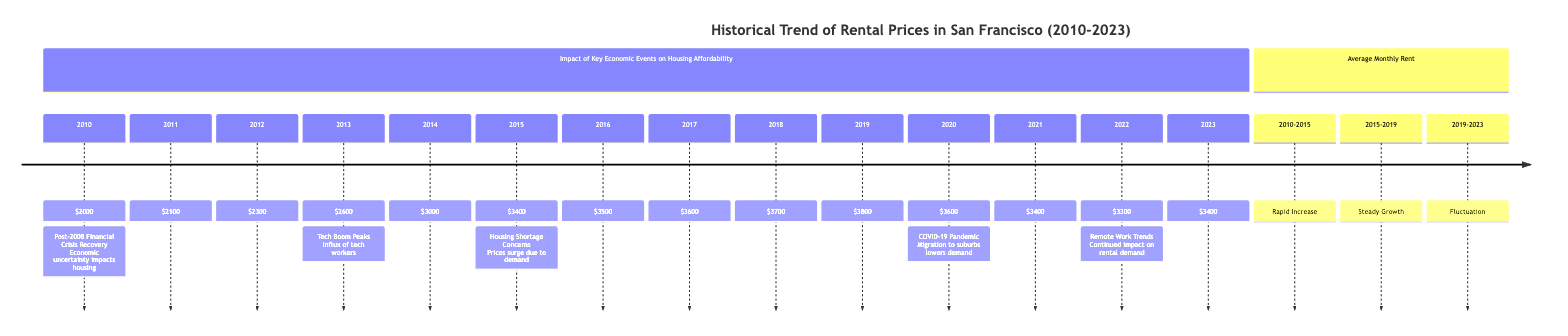What was the rental price in 2013? According to the diagram, the rental price in 2013 is marked as $2600.
Answer: $2600 What economic event is noted for 2020? The diagram indicates that the COVID-19 Pandemic is the key economic event for the year 2020.
Answer: COVID-19 Pandemic Which year saw the highest rental price? The rental price peaked in 2019 at $3800, making it the highest price in the provided timeline.
Answer: $3800 What was the rental price trend from 2010 to 2015? The section denotes that the rental price trend from 2010 to 2015 was marked as a Rapid Increase.
Answer: Rapid Increase In what year did rental prices first exceed $3000? The diagram shows that rental prices first exceeded $3000 in 2014.
Answer: 2014 What was the average rental price in 2022? According to the data represented, the average rental price in 2022 is $3300.
Answer: $3300 How did rental prices change from 2019 to 2020? The diagram depicts a decrease in rental prices from $3800 in 2019 to $3600 in 2020, indicating a decline.
Answer: Decrease What key economic concern is noted for 2015? The diagram cites Housing Shortage Concerns as a significant issue for the year 2015.
Answer: Housing Shortage Concerns What pattern is observed in the rental prices from 2019 to 2023? The section highlights that the trend during this period can be characterized as Fluctuation.
Answer: Fluctuation 